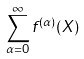<formula> <loc_0><loc_0><loc_500><loc_500>\sum _ { \alpha = 0 } ^ { \infty } f ^ { ( \alpha ) } ( X )</formula> 